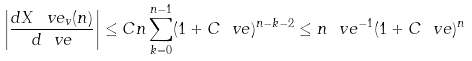<formula> <loc_0><loc_0><loc_500><loc_500>\left | \frac { d X ^ { \ } v e _ { v } ( n ) } { d \ v e } \right | \leq C n \sum _ { k = 0 } ^ { n - 1 } ( 1 + C \ v e ) ^ { n - k - 2 } \leq n \ v e ^ { - 1 } ( 1 + C \ v e ) ^ { n }</formula> 